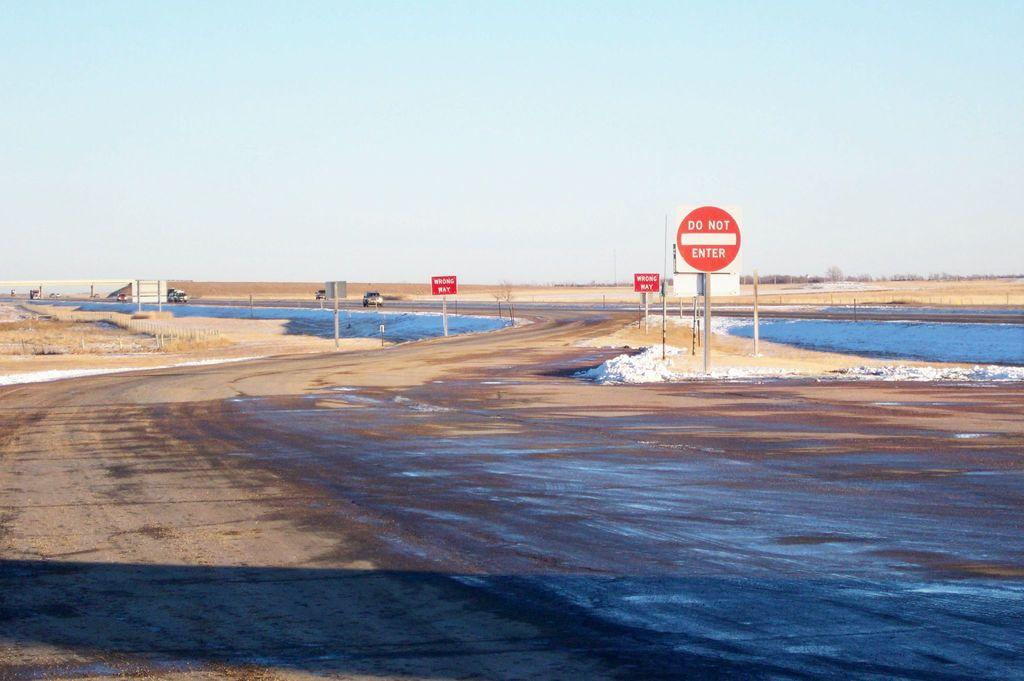<image>
Provide a brief description of the given image. An area by water has Do Not Enter and wrong ways signs posted. 